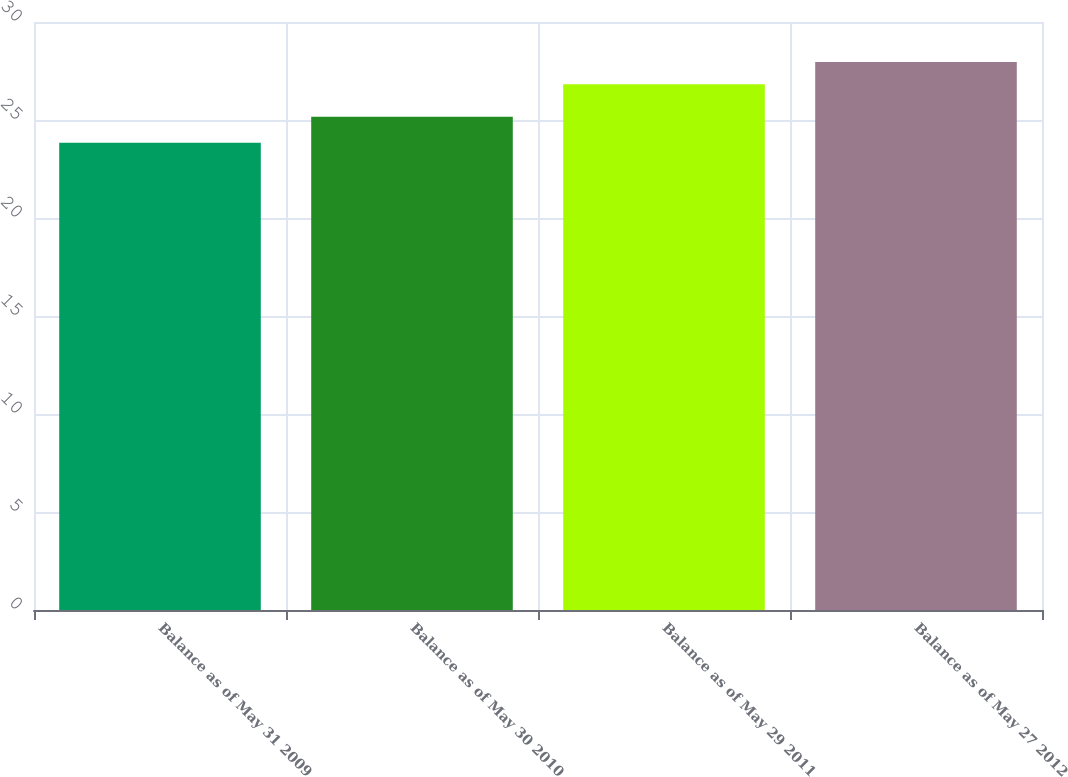Convert chart to OTSL. <chart><loc_0><loc_0><loc_500><loc_500><bar_chart><fcel>Balance as of May 31 2009<fcel>Balance as of May 30 2010<fcel>Balance as of May 29 2011<fcel>Balance as of May 27 2012<nl><fcel>23.84<fcel>25.17<fcel>26.82<fcel>27.96<nl></chart> 